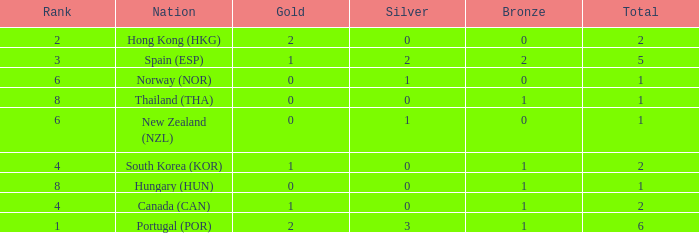What is the lowest Total containing a Bronze of 0 and Rank smaller than 2? None. 